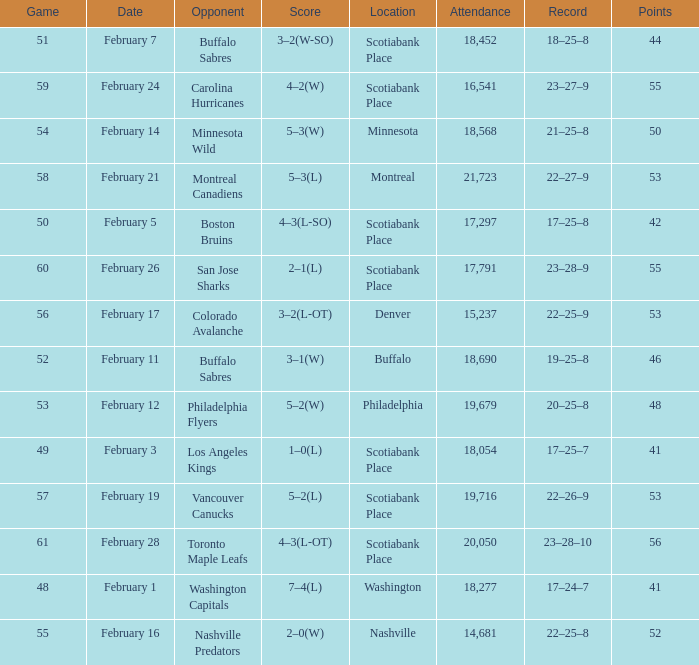What average game was held on february 24 and has an attendance smaller than 16,541? None. 